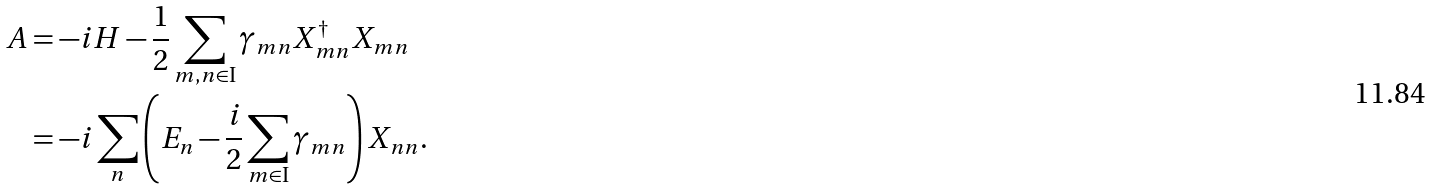Convert formula to latex. <formula><loc_0><loc_0><loc_500><loc_500>A & = - i H - \frac { 1 } { 2 } \sum _ { m , n \in \text {I} } \gamma _ { m n } X _ { m n } ^ { \dag } X _ { m n } \\ & = - i \sum _ { n } \left ( E _ { n } - \frac { i } { 2 } \sum _ { m \in \text {I} } \gamma _ { m n } \right ) X _ { n n } .</formula> 